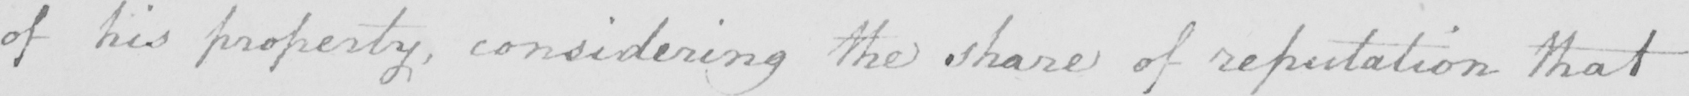Please transcribe the handwritten text in this image. of his property , considering the share of reputation that 